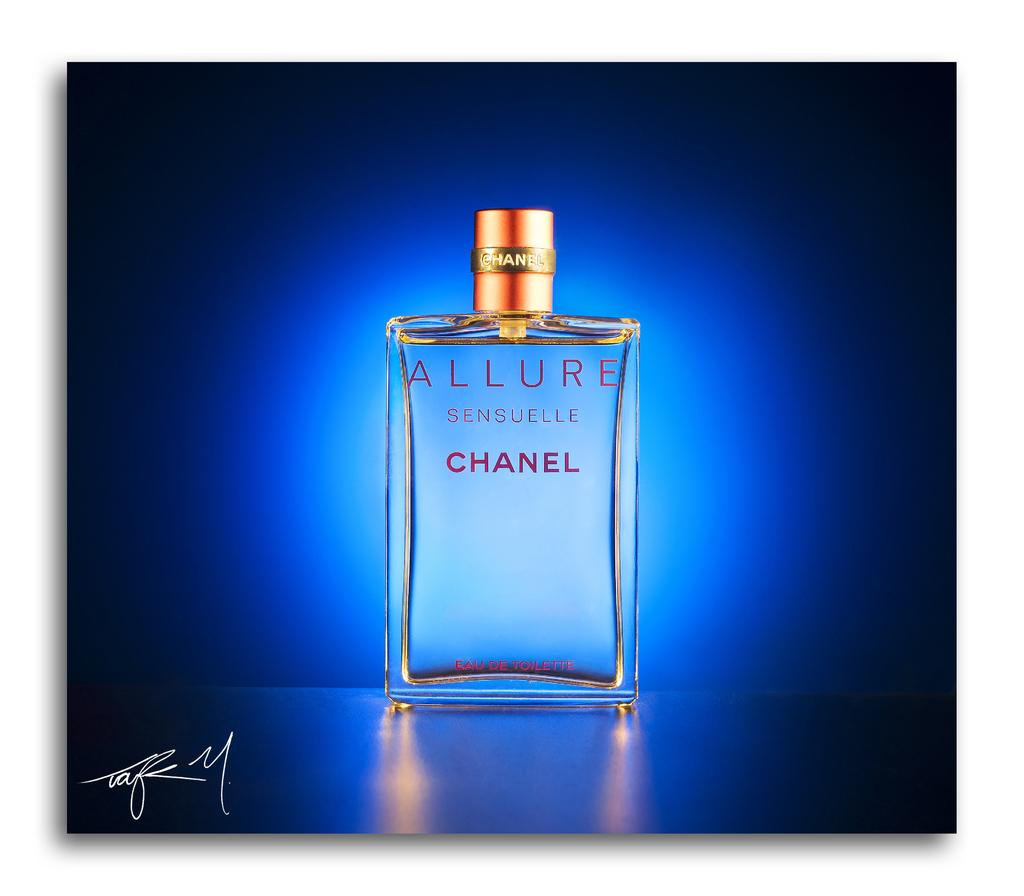Provide a one-sentence caption for the provided image. Allure by Chanel is etched into the side of this perfume bottle. 